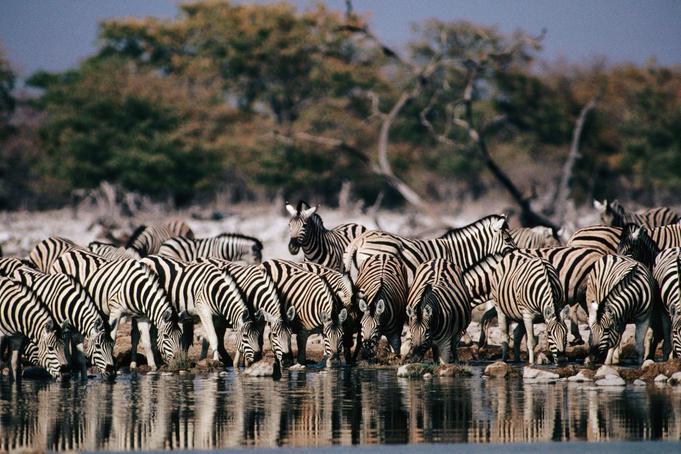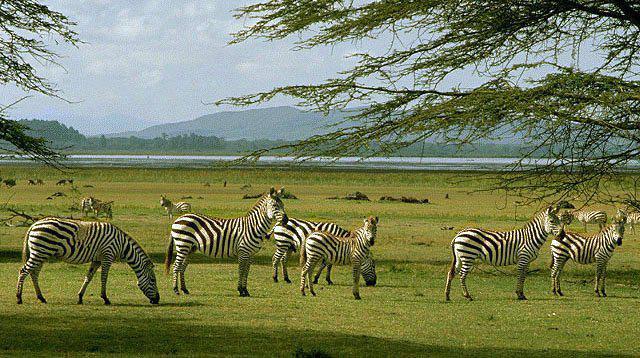The first image is the image on the left, the second image is the image on the right. Analyze the images presented: Is the assertion "There are clouds visible in the left image." valid? Answer yes or no. No. The first image is the image on the left, the second image is the image on the right. Assess this claim about the two images: "The right image shows dark hooved animals grazing behind zebra, and the left image shows zebra in a field with no watering hole visible.". Correct or not? Answer yes or no. No. 